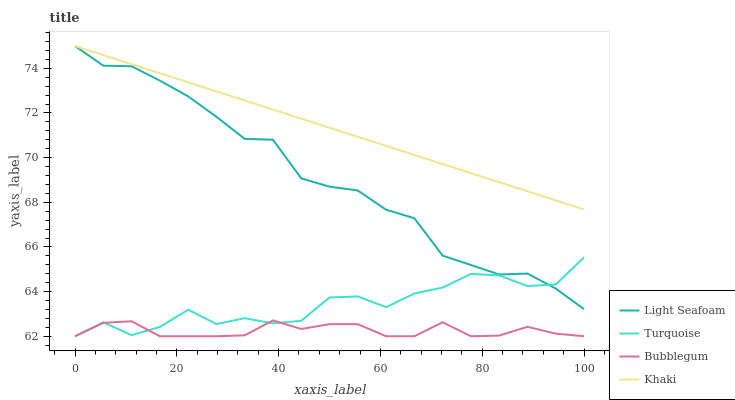Does Bubblegum have the minimum area under the curve?
Answer yes or no. Yes. Does Khaki have the maximum area under the curve?
Answer yes or no. Yes. Does Light Seafoam have the minimum area under the curve?
Answer yes or no. No. Does Light Seafoam have the maximum area under the curve?
Answer yes or no. No. Is Khaki the smoothest?
Answer yes or no. Yes. Is Turquoise the roughest?
Answer yes or no. Yes. Is Light Seafoam the smoothest?
Answer yes or no. No. Is Light Seafoam the roughest?
Answer yes or no. No. Does Turquoise have the lowest value?
Answer yes or no. Yes. Does Light Seafoam have the lowest value?
Answer yes or no. No. Does Khaki have the highest value?
Answer yes or no. Yes. Does Bubblegum have the highest value?
Answer yes or no. No. Is Bubblegum less than Khaki?
Answer yes or no. Yes. Is Khaki greater than Turquoise?
Answer yes or no. Yes. Does Bubblegum intersect Turquoise?
Answer yes or no. Yes. Is Bubblegum less than Turquoise?
Answer yes or no. No. Is Bubblegum greater than Turquoise?
Answer yes or no. No. Does Bubblegum intersect Khaki?
Answer yes or no. No. 